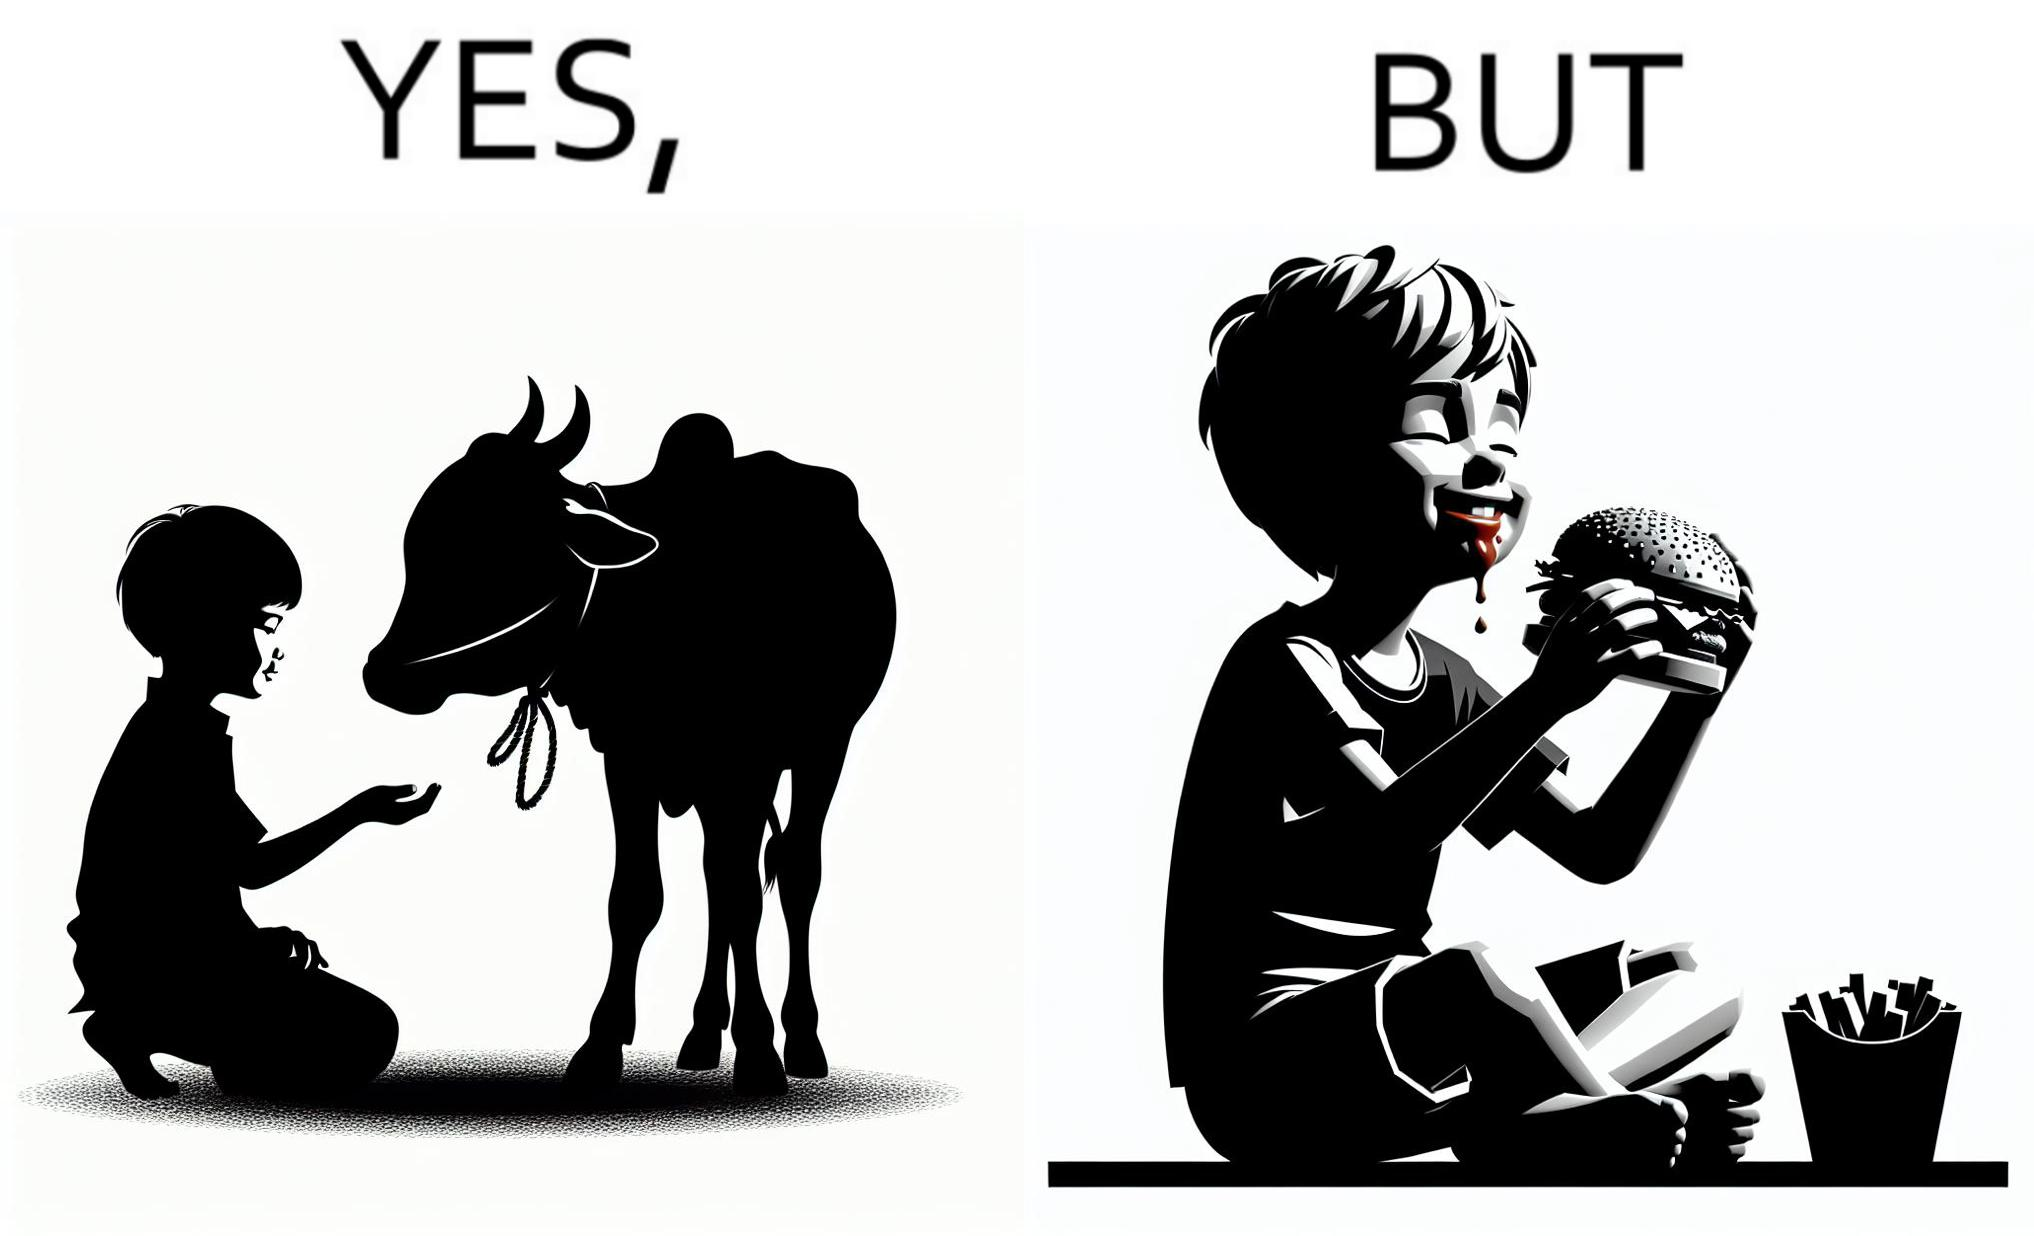Describe the content of this image. The irony is that the boy is petting the cow to show that he cares about the animal, but then he also eats hamburgers made from the same cows 